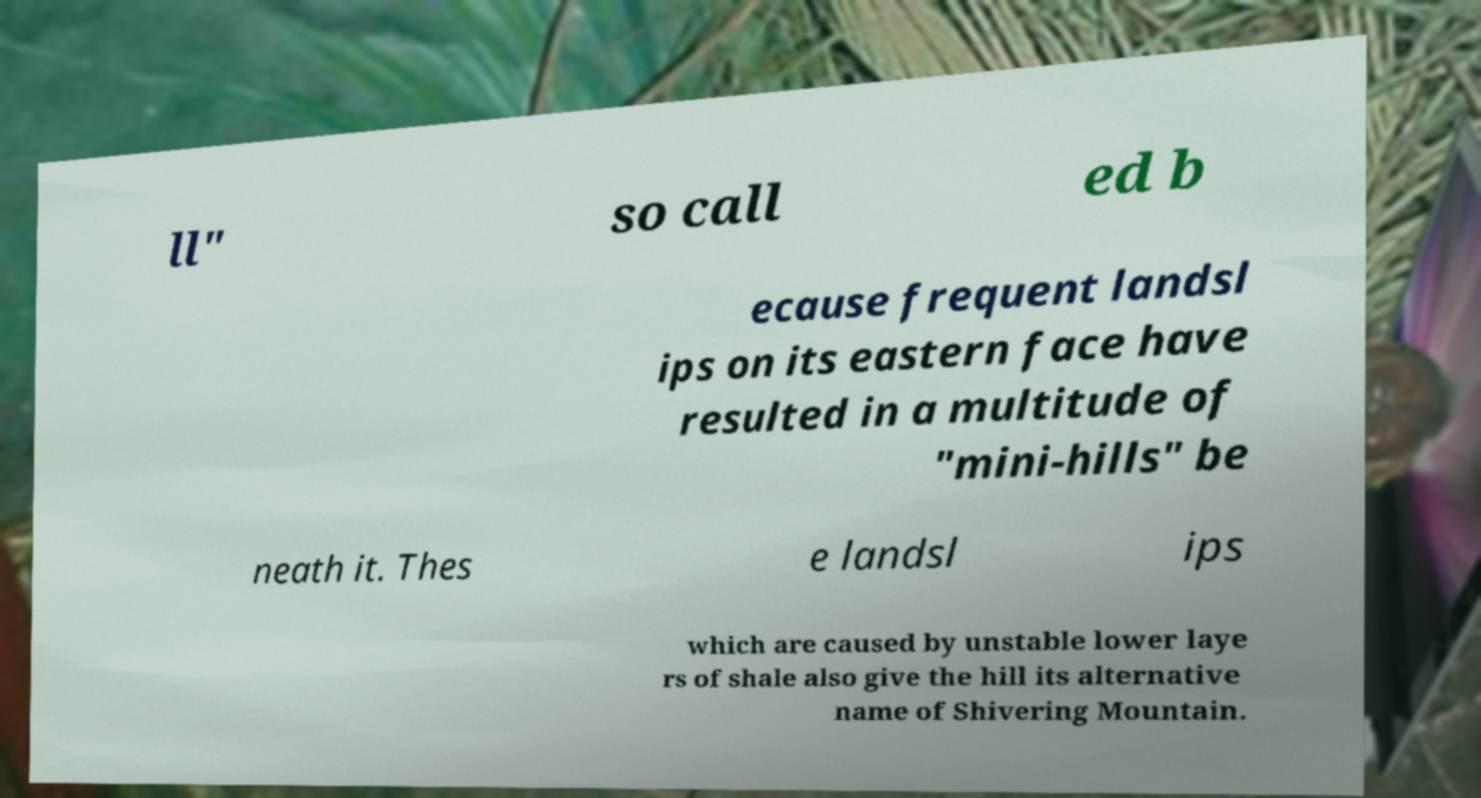Could you assist in decoding the text presented in this image and type it out clearly? ll" so call ed b ecause frequent landsl ips on its eastern face have resulted in a multitude of "mini-hills" be neath it. Thes e landsl ips which are caused by unstable lower laye rs of shale also give the hill its alternative name of Shivering Mountain. 